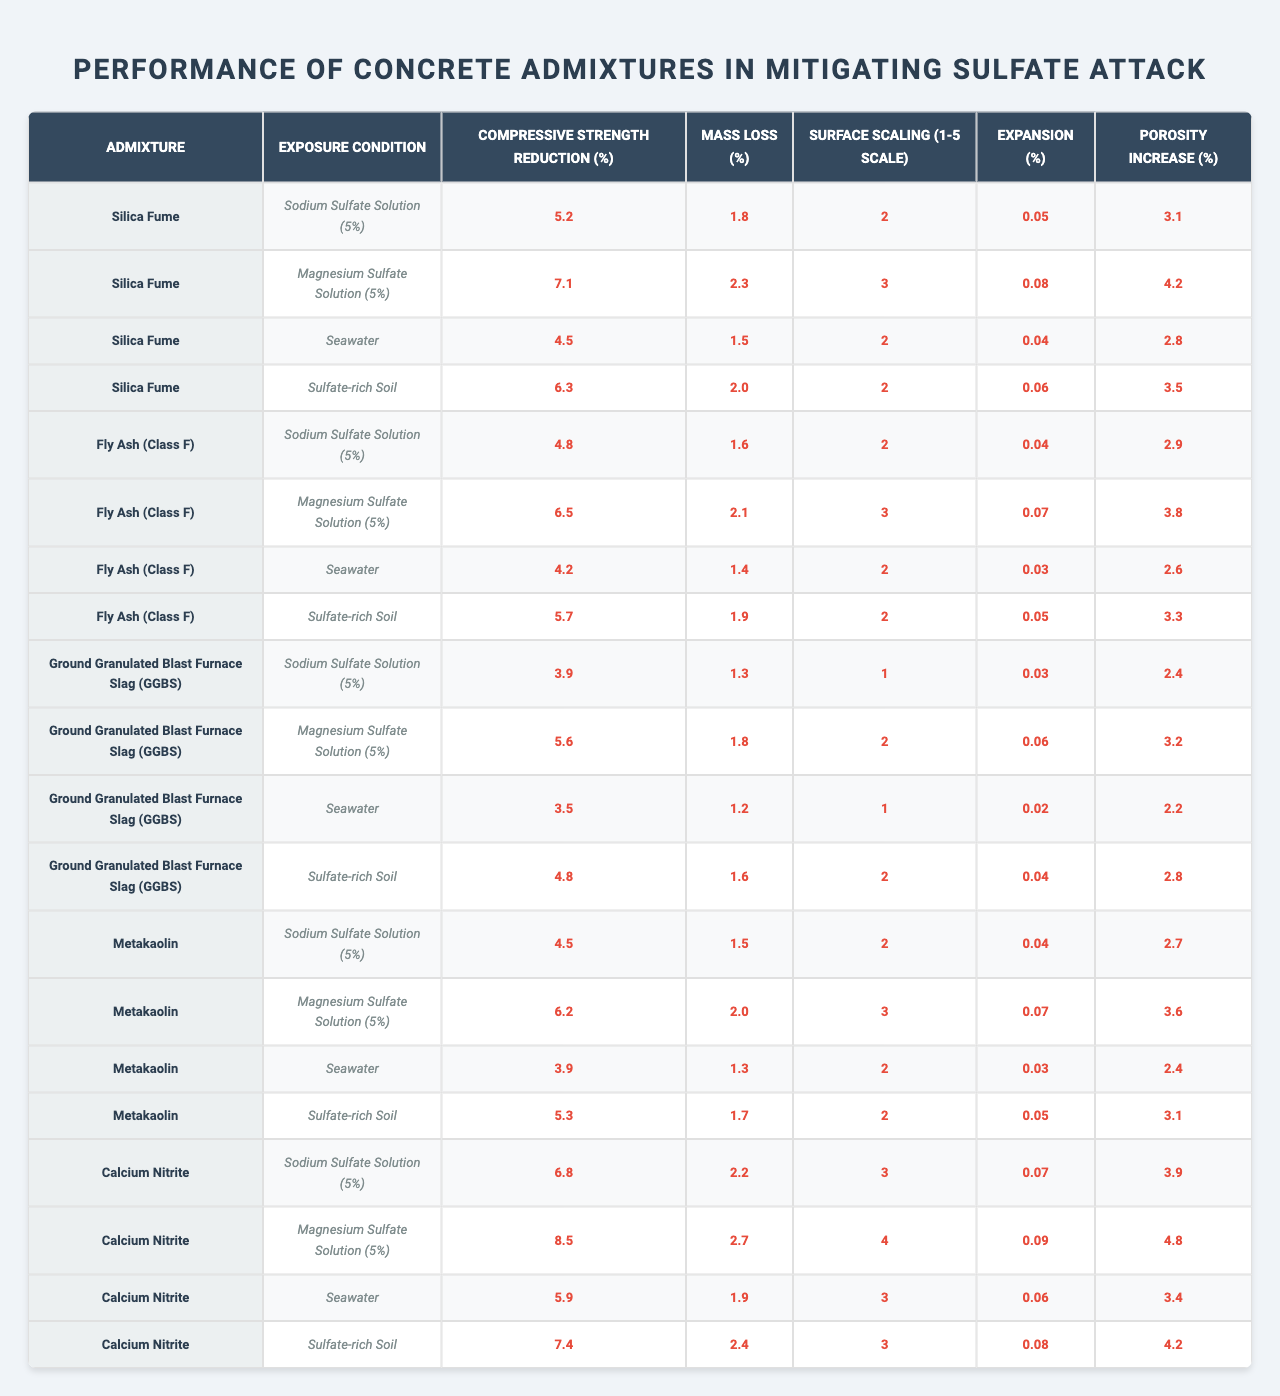What is the compressive strength reduction for Silica Fume in a Sodium Sulfate Solution (5%)? Looking at the table, the row for Silica Fume under the exposure condition of Sodium Sulfate Solution (5%) shows that the compressive strength reduction is 5.2%.
Answer: 5.2% Which admixture demonstrates the highest mass loss in Magnesium Sulfate Solution (5%)? In the table, the row for Calcium Nitrite under Magnesium Sulfate Solution (5%) indicates a mass loss of 2.7%, which is greater than the values for all other admixtures listed in that exposure condition.
Answer: Calcium Nitrite What is the average compressive strength reduction for Fly Ash (Class F) across all exposure conditions? The compressive strength reductions for Fly Ash (Class F) are: 4.8%, 6.5%, 4.2%, and 5.7%. Summing these values gives 21.2%. Dividing by the number of exposure conditions (4) results in an average of 5.3%.
Answer: 5.3% Does Ground Granulated Blast Furnace Slag (GGBS) perform better or worse than Fly Ash (Class F) in terms of compressive strength reduction in a Seawater exposure? For GGBS in Seawater, the compressive strength reduction is 3.5%, while for Fly Ash (Class F) it is 4.2%. Since 3.5% is less than 4.2%, GGBS performs better in this case.
Answer: Better What is the difference in surface scaling between Calcium Nitrite and Silica Fume in Magnesium Sulfate Solution (5%)? For Calcium Nitrite, the surface scaling is rated at 4, while for Silica Fume, it is rated at 3. The difference in surface scaling is 4 - 3 = 1.
Answer: 1 Which admixture has the lowest increase in porosity in a Sulfate-rich Soil exposure? In the table, the increase in porosity for the different admixtures in Sulfate-rich Soil are as follows: Calcium Nitrite (4.2%), Silica Fume (3.5%), Fly Ash (3.3%), Metakaolin (3.1%), and GGBS (2.8%). The lowest value is for GGBS at 2.4%.
Answer: GGBS What is the maximum expansion observed across all admixtures in a Sodium Sulfate Solution (5%) exposure? Reviewing the table for Sodium Sulfate Solution (5%), the highest expansion value is 0.08%, associated with Silica Fume and Calcium Nitrite, which are both at 0.07%.
Answer: 0.08% In general, which admixture performs the best in terms of overall durability against sulfate attack based on the provided metrics? By analyzing the compressive strength reduction, mass loss, surface scaling, expansion, and porosity increase for each admixture across all exposure conditions, GGBS consistently shows lower values than others, indicating better performance overall.
Answer: GGBS How many admixtures show a surface scaling of 2 or less under Seawater exposure conditions? In the row for Seawater, the following admixtures have a surface scaling of 2 or less: Silica Fume, GGBS, and Metakaolin. This gives a total of 3 admixtures.
Answer: 3 What exposure condition resulted in the highest porosity increase for Metakaolin? According to the data for Metakaolin, the highest porosity increase occurs under Magnesium Sulfate Solution (5%) with a value of 3.6%.
Answer: Magnesium Sulfate Solution (5%) 